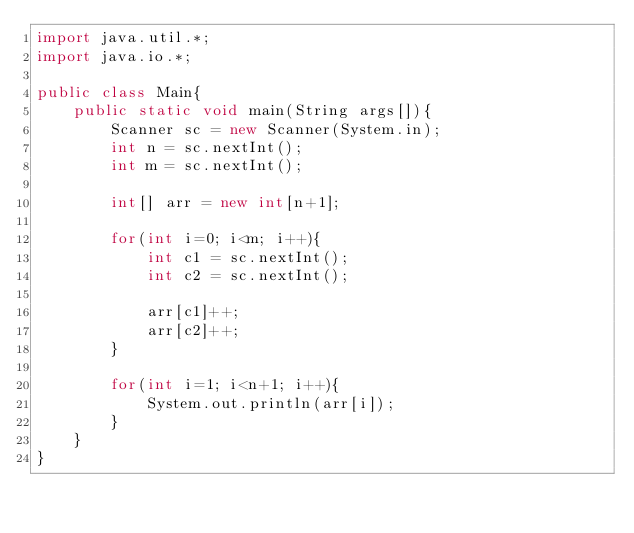<code> <loc_0><loc_0><loc_500><loc_500><_Java_>import java.util.*;
import java.io.*;

public class Main{
	public static void main(String args[]){
		Scanner sc = new Scanner(System.in);
		int n = sc.nextInt();
		int m = sc.nextInt();
	
		int[] arr = new int[n+1];
		
		for(int i=0; i<m; i++){
			int c1 = sc.nextInt();
			int c2 = sc.nextInt();
			
			arr[c1]++;
			arr[c2]++;
		}
		
		for(int i=1; i<n+1; i++){
			System.out.println(arr[i]);
		}
	}
}</code> 